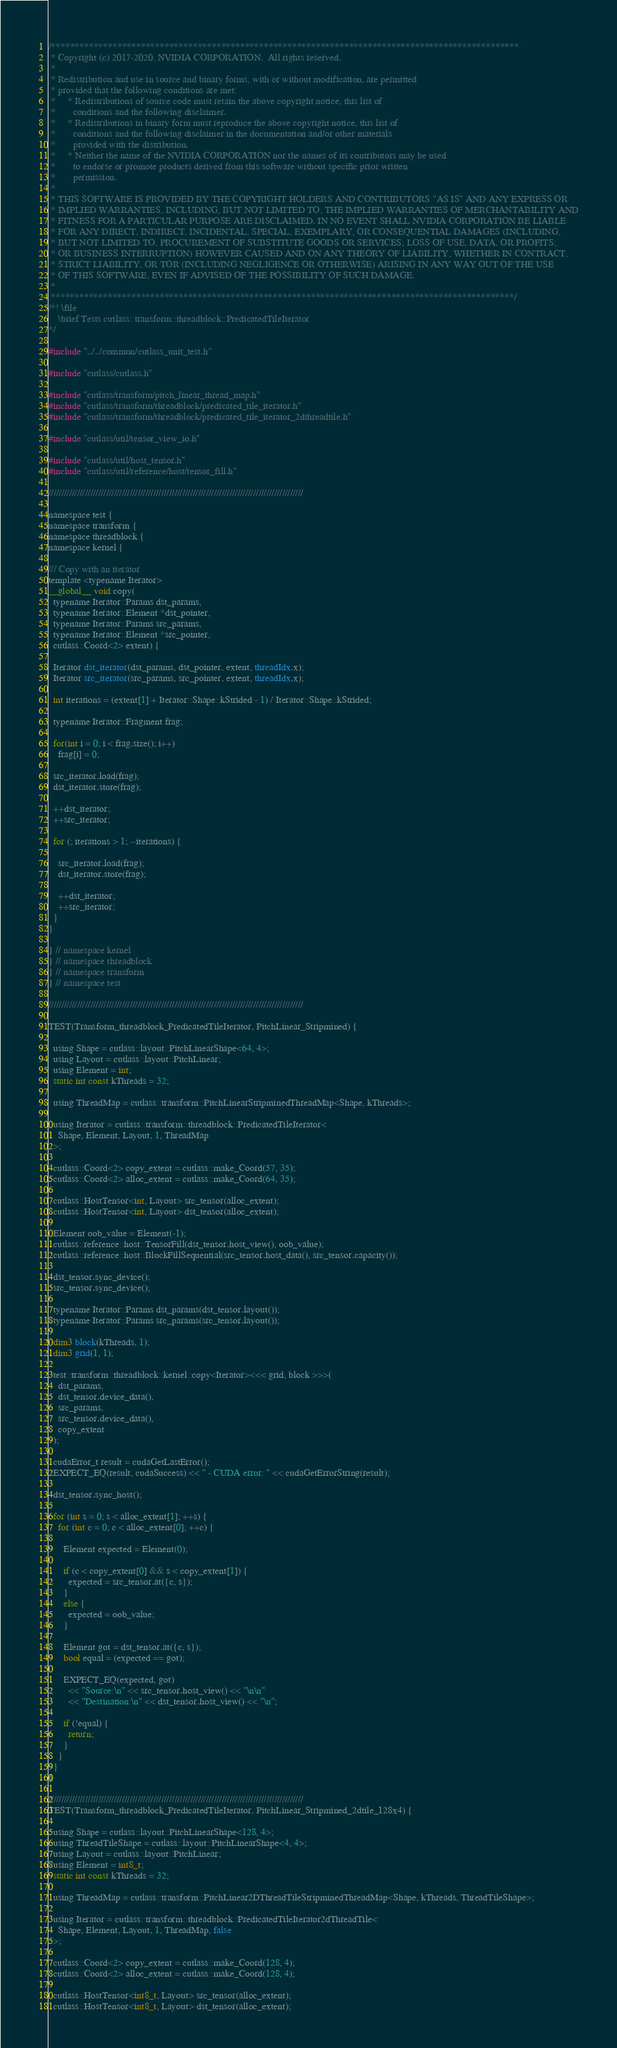<code> <loc_0><loc_0><loc_500><loc_500><_Cuda_>/***************************************************************************************************
 * Copyright (c) 2017-2020, NVIDIA CORPORATION.  All rights reserved.
 *
 * Redistribution and use in source and binary forms, with or without modification, are permitted
 * provided that the following conditions are met:
 *     * Redistributions of source code must retain the above copyright notice, this list of
 *       conditions and the following disclaimer.
 *     * Redistributions in binary form must reproduce the above copyright notice, this list of
 *       conditions and the following disclaimer in the documentation and/or other materials
 *       provided with the distribution.
 *     * Neither the name of the NVIDIA CORPORATION nor the names of its contributors may be used
 *       to endorse or promote products derived from this software without specific prior written
 *       permission.
 *
 * THIS SOFTWARE IS PROVIDED BY THE COPYRIGHT HOLDERS AND CONTRIBUTORS "AS IS" AND ANY EXPRESS OR
 * IMPLIED WARRANTIES, INCLUDING, BUT NOT LIMITED TO, THE IMPLIED WARRANTIES OF MERCHANTABILITY AND
 * FITNESS FOR A PARTICULAR PURPOSE ARE DISCLAIMED. IN NO EVENT SHALL NVIDIA CORPORATION BE LIABLE
 * FOR ANY DIRECT, INDIRECT, INCIDENTAL, SPECIAL, EXEMPLARY, OR CONSEQUENTIAL DAMAGES (INCLUDING,
 * BUT NOT LIMITED TO, PROCUREMENT OF SUBSTITUTE GOODS OR SERVICES; LOSS OF USE, DATA, OR PROFITS;
 * OR BUSINESS INTERRUPTION) HOWEVER CAUSED AND ON ANY THEORY OF LIABILITY, WHETHER IN CONTRACT,
 * STRICT LIABILITY, OR TOR (INCLUDING NEGLIGENCE OR OTHERWISE) ARISING IN ANY WAY OUT OF THE USE
 * OF THIS SOFTWARE, EVEN IF ADVISED OF THE POSSIBILITY OF SUCH DAMAGE.
 *
 **************************************************************************************************/
/*! \file
    \brief Tests cutlass::transform::threadblock::PredicatedTileIterator 
*/

#include "../../common/cutlass_unit_test.h"

#include "cutlass/cutlass.h"

#include "cutlass/transform/pitch_linear_thread_map.h"
#include "cutlass/transform/threadblock/predicated_tile_iterator.h"
#include "cutlass/transform/threadblock/predicated_tile_iterator_2dthreadtile.h"

#include "cutlass/util/tensor_view_io.h"

#include "cutlass/util/host_tensor.h"
#include "cutlass/util/reference/host/tensor_fill.h"

/////////////////////////////////////////////////////////////////////////////////////////////////

namespace test {
namespace transform {
namespace threadblock {
namespace kernel {

/// Copy with an iterator
template <typename Iterator>
__global__ void copy(
  typename Iterator::Params dst_params, 
  typename Iterator::Element *dst_pointer,
  typename Iterator::Params src_params,
  typename Iterator::Element *src_pointer,
  cutlass::Coord<2> extent) {

  Iterator dst_iterator(dst_params, dst_pointer, extent, threadIdx.x);
  Iterator src_iterator(src_params, src_pointer, extent, threadIdx.x);

  int iterations = (extent[1] + Iterator::Shape::kStrided - 1) / Iterator::Shape::kStrided;

  typename Iterator::Fragment frag;

  for(int i = 0; i < frag.size(); i++)
    frag[i] = 0;

  src_iterator.load(frag);
  dst_iterator.store(frag);

  ++dst_iterator;
  ++src_iterator;

  for (; iterations > 1; --iterations) {
    
    src_iterator.load(frag);
    dst_iterator.store(frag);

    ++dst_iterator;
    ++src_iterator;
  }
}

} // namespace kernel
} // namespace threadblock
} // namespace transform
} // namespace test

/////////////////////////////////////////////////////////////////////////////////////////////////

TEST(Transform_threadblock_PredicatedTileIterator, PitchLinear_Stripmined) {

  using Shape = cutlass::layout::PitchLinearShape<64, 4>;
  using Layout = cutlass::layout::PitchLinear;
  using Element = int;
  static int const kThreads = 32;
  
  using ThreadMap = cutlass::transform::PitchLinearStripminedThreadMap<Shape, kThreads>;

  using Iterator = cutlass::transform::threadblock::PredicatedTileIterator<
    Shape, Element, Layout, 1, ThreadMap
  >;

  cutlass::Coord<2> copy_extent = cutlass::make_Coord(57, 35);
  cutlass::Coord<2> alloc_extent = cutlass::make_Coord(64, 35);
  
  cutlass::HostTensor<int, Layout> src_tensor(alloc_extent);
  cutlass::HostTensor<int, Layout> dst_tensor(alloc_extent);

  Element oob_value = Element(-1);
  cutlass::reference::host::TensorFill(dst_tensor.host_view(), oob_value);
  cutlass::reference::host::BlockFillSequential(src_tensor.host_data(), src_tensor.capacity());

  dst_tensor.sync_device();
  src_tensor.sync_device();

  typename Iterator::Params dst_params(dst_tensor.layout());
  typename Iterator::Params src_params(src_tensor.layout());

  dim3 block(kThreads, 1);
  dim3 grid(1, 1);

  test::transform::threadblock::kernel::copy<Iterator><<< grid, block >>>(
    dst_params,
    dst_tensor.device_data(),
    src_params,
    src_tensor.device_data(),
    copy_extent
  );

  cudaError_t result = cudaGetLastError();
  EXPECT_EQ(result, cudaSuccess) << " - CUDA error: " << cudaGetErrorString(result);
  
  dst_tensor.sync_host();

  for (int s = 0; s < alloc_extent[1]; ++s) {
    for (int c = 0; c < alloc_extent[0]; ++c) {

      Element expected = Element(0);

      if (c < copy_extent[0] && s < copy_extent[1]) {
        expected = src_tensor.at({c, s});
      }
      else {
        expected = oob_value;
      }

      Element got = dst_tensor.at({c, s});
      bool equal = (expected == got);

      EXPECT_EQ(expected, got)
        << "Source:\n" << src_tensor.host_view() << "\n\n"
        << "Destination:\n" << dst_tensor.host_view() << "\n";

      if (!equal) {
        return;
      }
    }
  }
}

/////////////////////////////////////////////////////////////////////////////////////////////////
TEST(Transform_threadblock_PredicatedTileIterator, PitchLinear_Stripmined_2dtile_128x4) {

  using Shape = cutlass::layout::PitchLinearShape<128, 4>;
  using ThreadTileShape = cutlass::layout::PitchLinearShape<4, 4>;
  using Layout = cutlass::layout::PitchLinear;
  using Element = int8_t;
  static int const kThreads = 32;
  
  using ThreadMap = cutlass::transform::PitchLinear2DThreadTileStripminedThreadMap<Shape, kThreads, ThreadTileShape>;

  using Iterator = cutlass::transform::threadblock::PredicatedTileIterator2dThreadTile<
    Shape, Element, Layout, 1, ThreadMap, false
  >;

  cutlass::Coord<2> copy_extent = cutlass::make_Coord(128, 4);
  cutlass::Coord<2> alloc_extent = cutlass::make_Coord(128, 4);
  
  cutlass::HostTensor<int8_t, Layout> src_tensor(alloc_extent);
  cutlass::HostTensor<int8_t, Layout> dst_tensor(alloc_extent);
</code> 